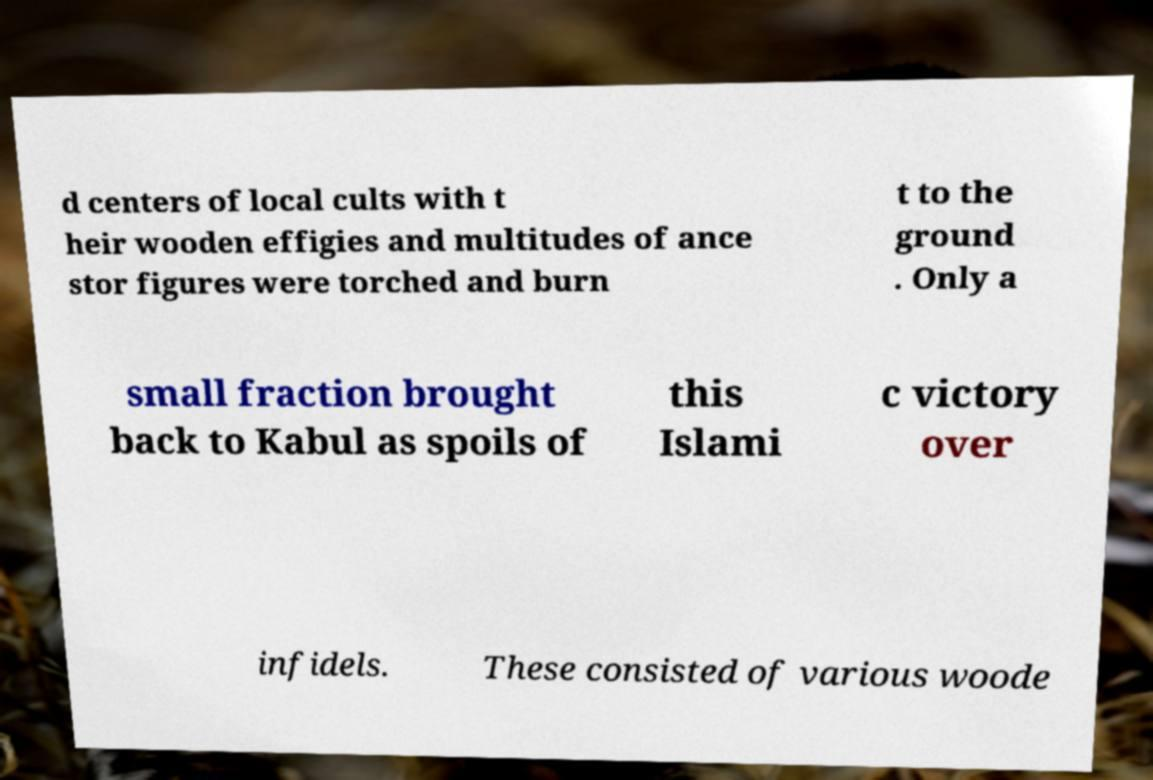For documentation purposes, I need the text within this image transcribed. Could you provide that? d centers of local cults with t heir wooden effigies and multitudes of ance stor figures were torched and burn t to the ground . Only a small fraction brought back to Kabul as spoils of this Islami c victory over infidels. These consisted of various woode 